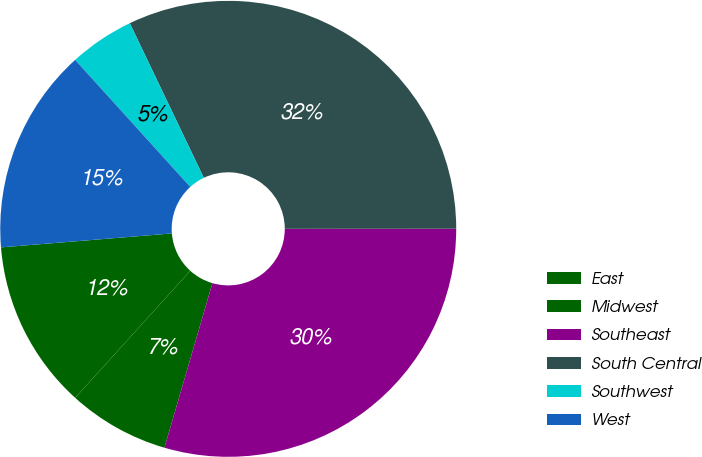<chart> <loc_0><loc_0><loc_500><loc_500><pie_chart><fcel>East<fcel>Midwest<fcel>Southeast<fcel>South Central<fcel>Southwest<fcel>West<nl><fcel>11.99%<fcel>7.2%<fcel>29.52%<fcel>32.1%<fcel>4.61%<fcel>14.58%<nl></chart> 